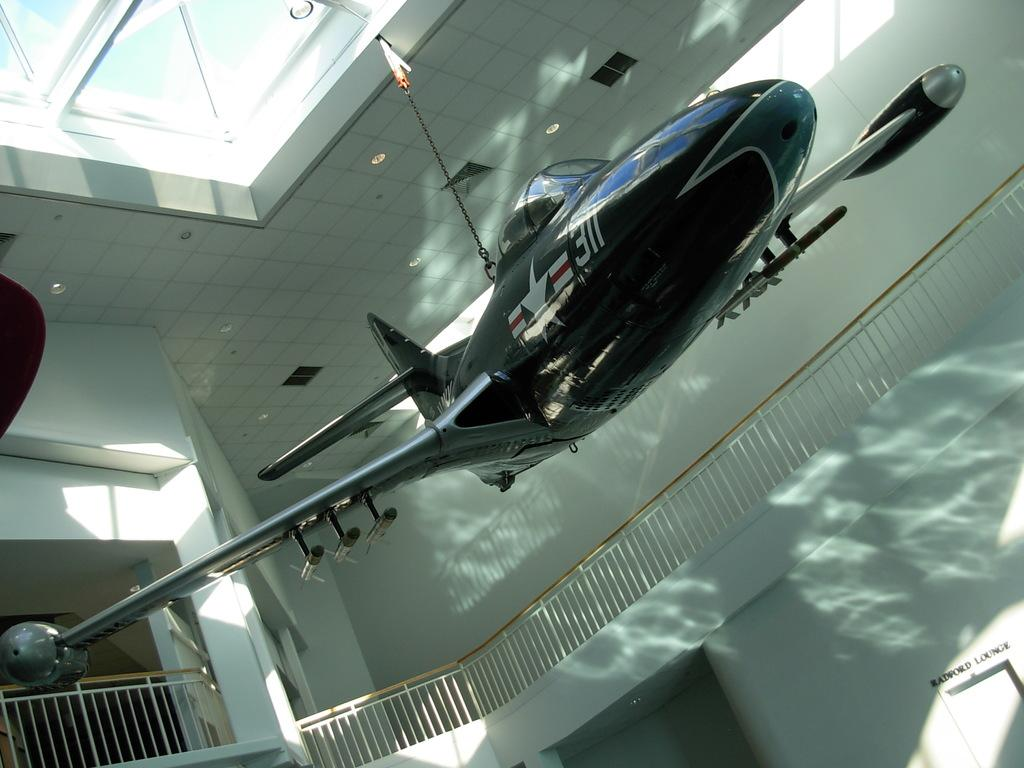What is hanging from the top in the image? There is an aircraft hanging from the top in the image. What type of structure can be seen in the image? There are iron railings in the image. Where is the window located in the image? There is a window at the top of the image. What month is depicted in the image? There is no indication of a specific month in the image. Can you see any stars in the image? There are no stars visible in the image. 